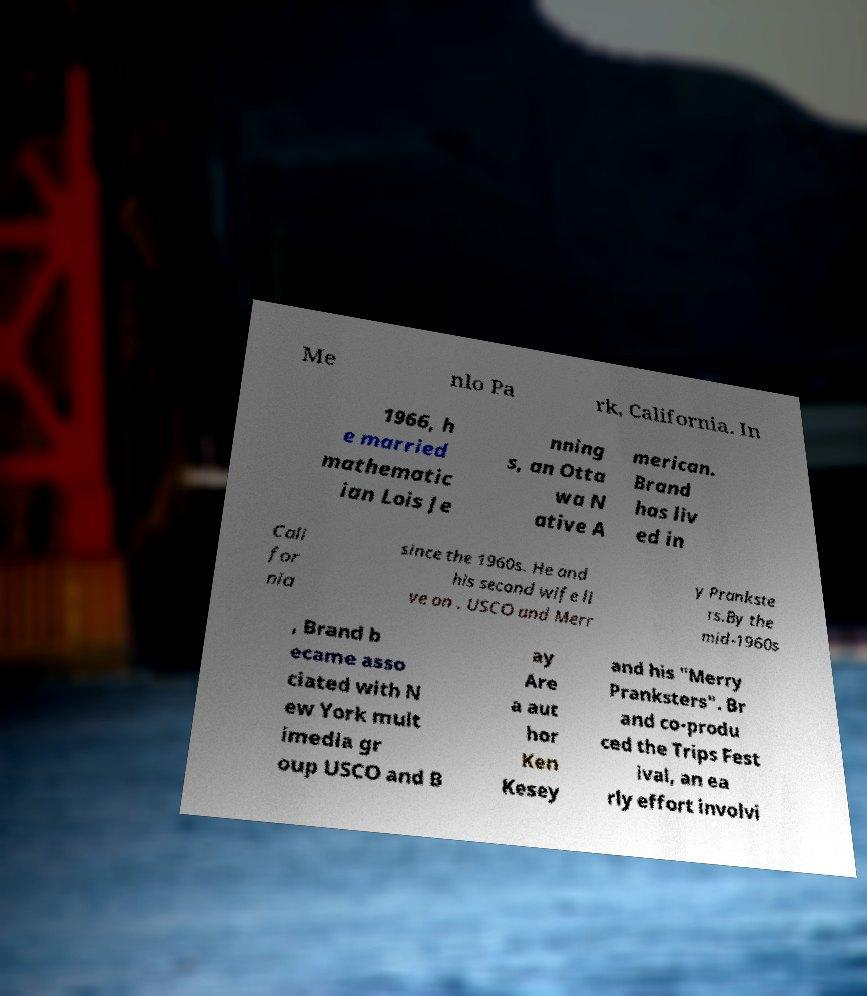Please identify and transcribe the text found in this image. Me nlo Pa rk, California. In 1966, h e married mathematic ian Lois Je nning s, an Otta wa N ative A merican. Brand has liv ed in Cali for nia since the 1960s. He and his second wife li ve on . USCO and Merr y Prankste rs.By the mid-1960s , Brand b ecame asso ciated with N ew York mult imedia gr oup USCO and B ay Are a aut hor Ken Kesey and his "Merry Pranksters". Br and co-produ ced the Trips Fest ival, an ea rly effort involvi 